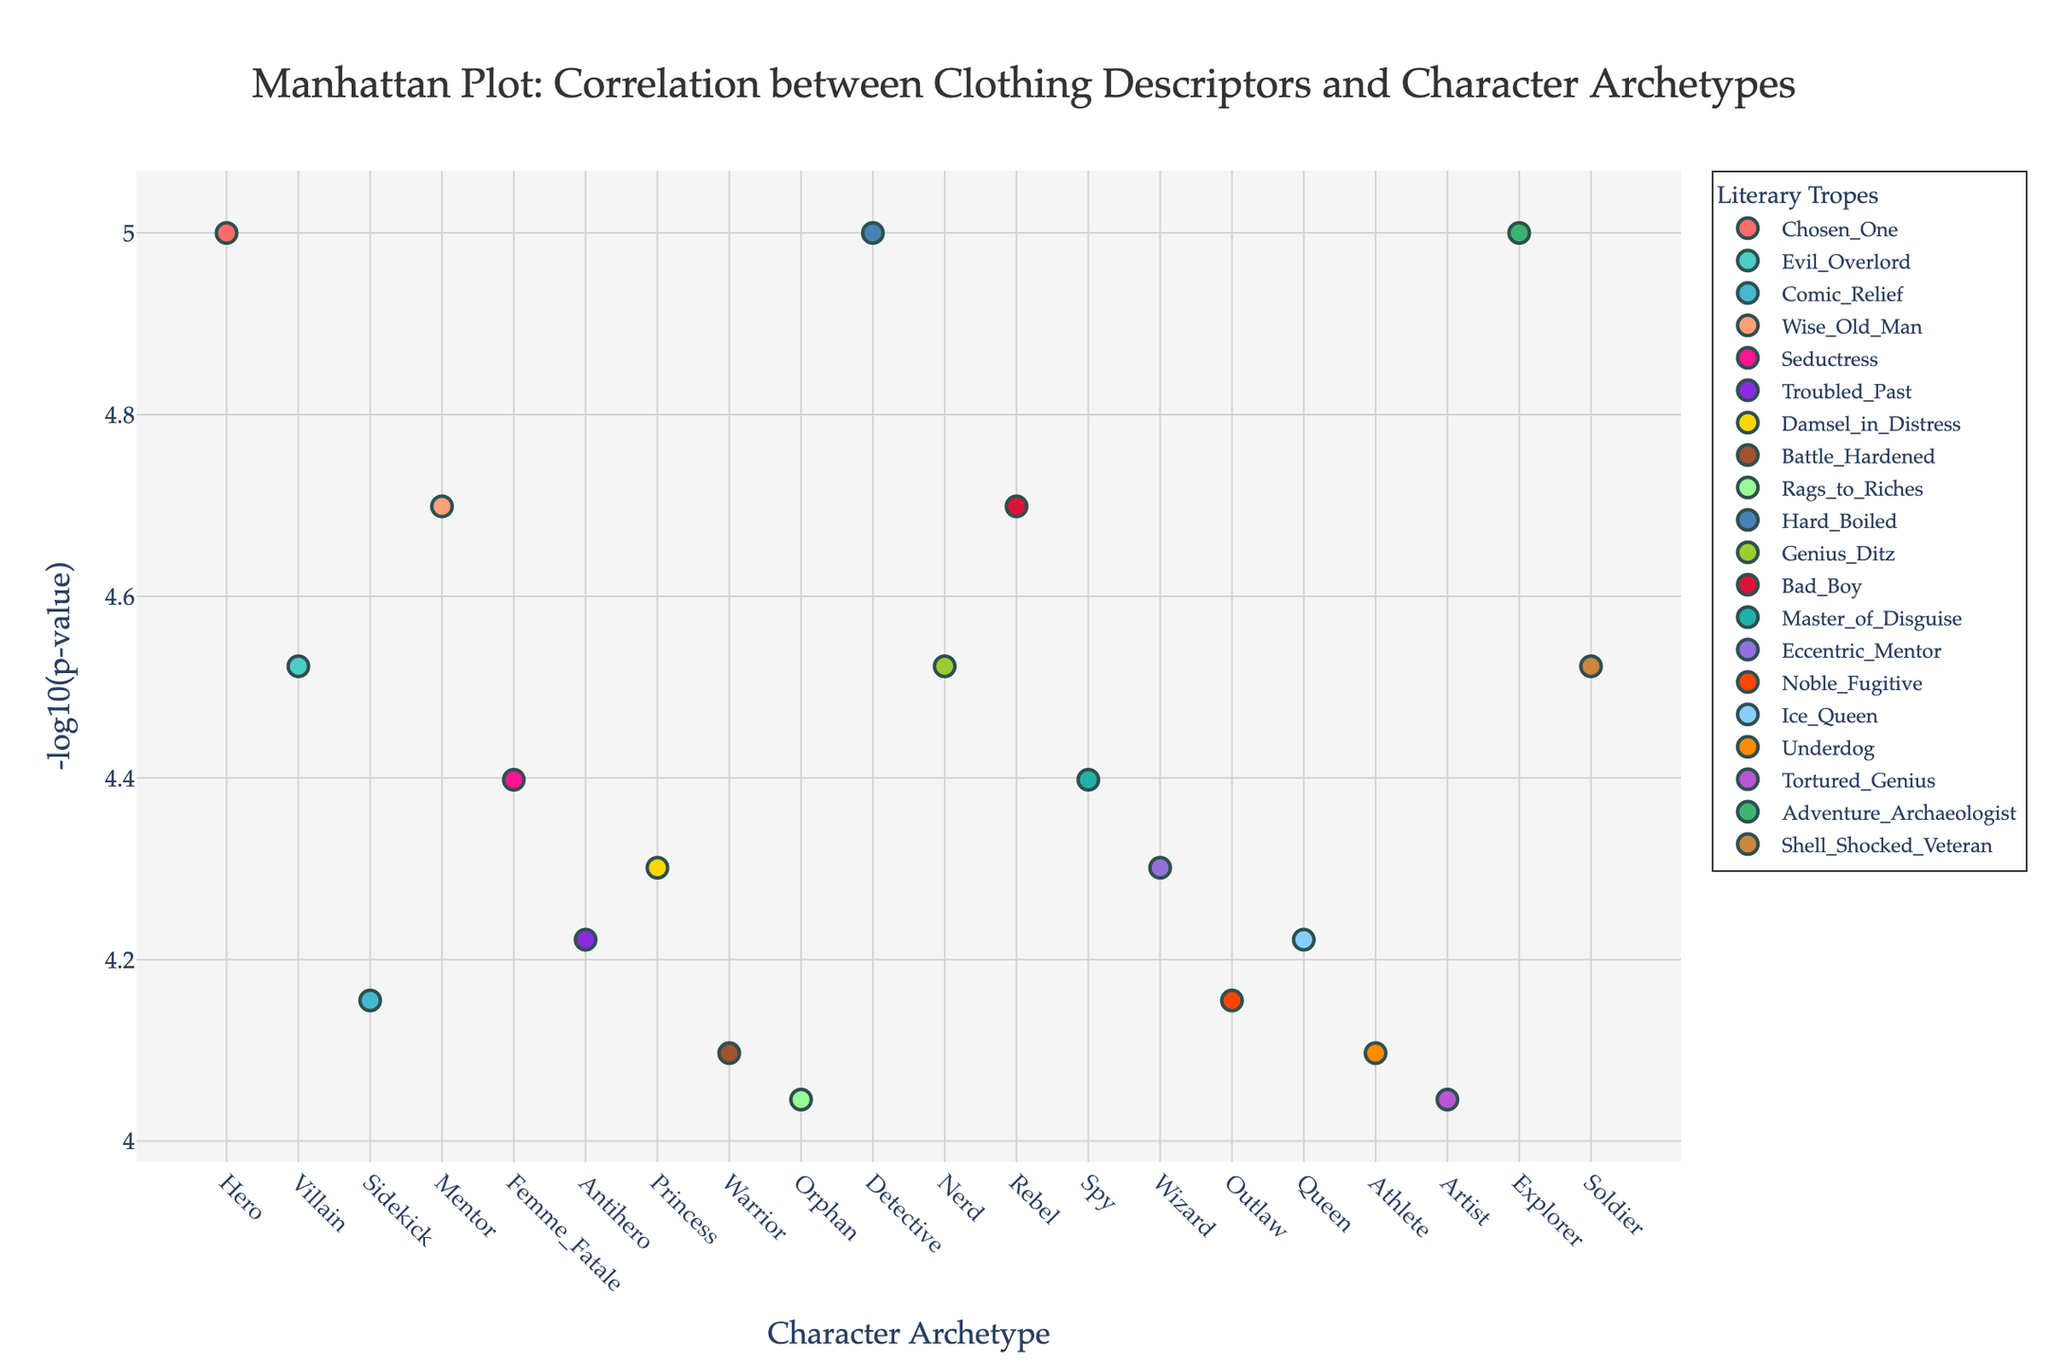What is the title of the plot? The title of the plot is centrally positioned at the top part of the figure and it reads "Manhattan Plot: Correlation between Clothing Descriptors and Character Archetypes".
Answer: "Manhattan Plot: Correlation between Clothing Descriptors and Character Archetypes" Which character archetype corresponds to the highest -log10(p-value)? To find the highest -log10(p-value), look at the y-axis for the maximum value and trace it to the corresponding character archetype on the x-axis. The value is associated with "Hero".
Answer: Hero How many clothing descriptors are associated with the trope 'Comic Relief'? To determine the number of data points associated with 'Comic Relief', look for the relevant entries in the legend and count the markers of the indicated color in the plot. Here, there is 1 data point, which corresponds to "Quirky Accessories" for the "Sidekick" character archetype.
Answer: 1 Which trope has character archetypes with the smallest and largest -log10(p-value)? To determine this, locate the highest and lowest points on the y-axis and identify their tropes from the corresponding legend. The smallest and largest -log10(p-values) are found in the "Adventure Archaeologist" (Explorer) and "Chosen One" (Hero) tropes, both having the same maximum value.
Answer: Adventure Archaeologist, Chosen One Is the character archetype 'Villain' more strongly correlated with 'Black Cape' or 'Crown'? Find the -log10(p-values) for both 'Villain' related clothing descriptors and compare. "Black Cape" has a higher -log10(p-value) compared to "Crown", indicating a stronger correlation.
Answer: Black Cape What is the -log10(p-value) range for the trope 'Seductress'? Identify the -log10(p-values) corresponding to the 'Seductress' trope, which is "Red Dress" for the "Femme Fatale" character. The range is calculated by noting its single data point's -log10(p-value), which is approximately the value shown.
Answer: Approximately 4.97 Which character archetypes are associated with the 'Rags_to_Riches' trope? To find the character archetypes for a specific trope, look at the relevant section of the legend, and match those colors to the data points. The 'Rags to Riches' trope is associated with "Orphan".
Answer: Orphan How does the -log10(p-value) for 'Explorer' compare to 'Hard Boiled'? Locate the -log10(p-values) for both 'Explorer' and 'Detective' (Hard Boiled). The values show that 'Explorer' has a higher -log10(p-value) compared to 'Hard Boiled', indicating a stronger correlation.
Answer: Explorer is higher What is the total count of character archetypes that have a -log10(p-value) above 4? Count all the data points which have -log10(p-values) exceeding 4 by looking at the y-axis and counting distinct markers above this threshold. There are 5 such points.
Answer: 5 Which trope is represented by the color '#20B2AA' in the plot? Match the color '#20B2AA' to its labeled trope in the legend. The color corresponds to the 'Master of Disguise' trope.
Answer: Master of Disguise 